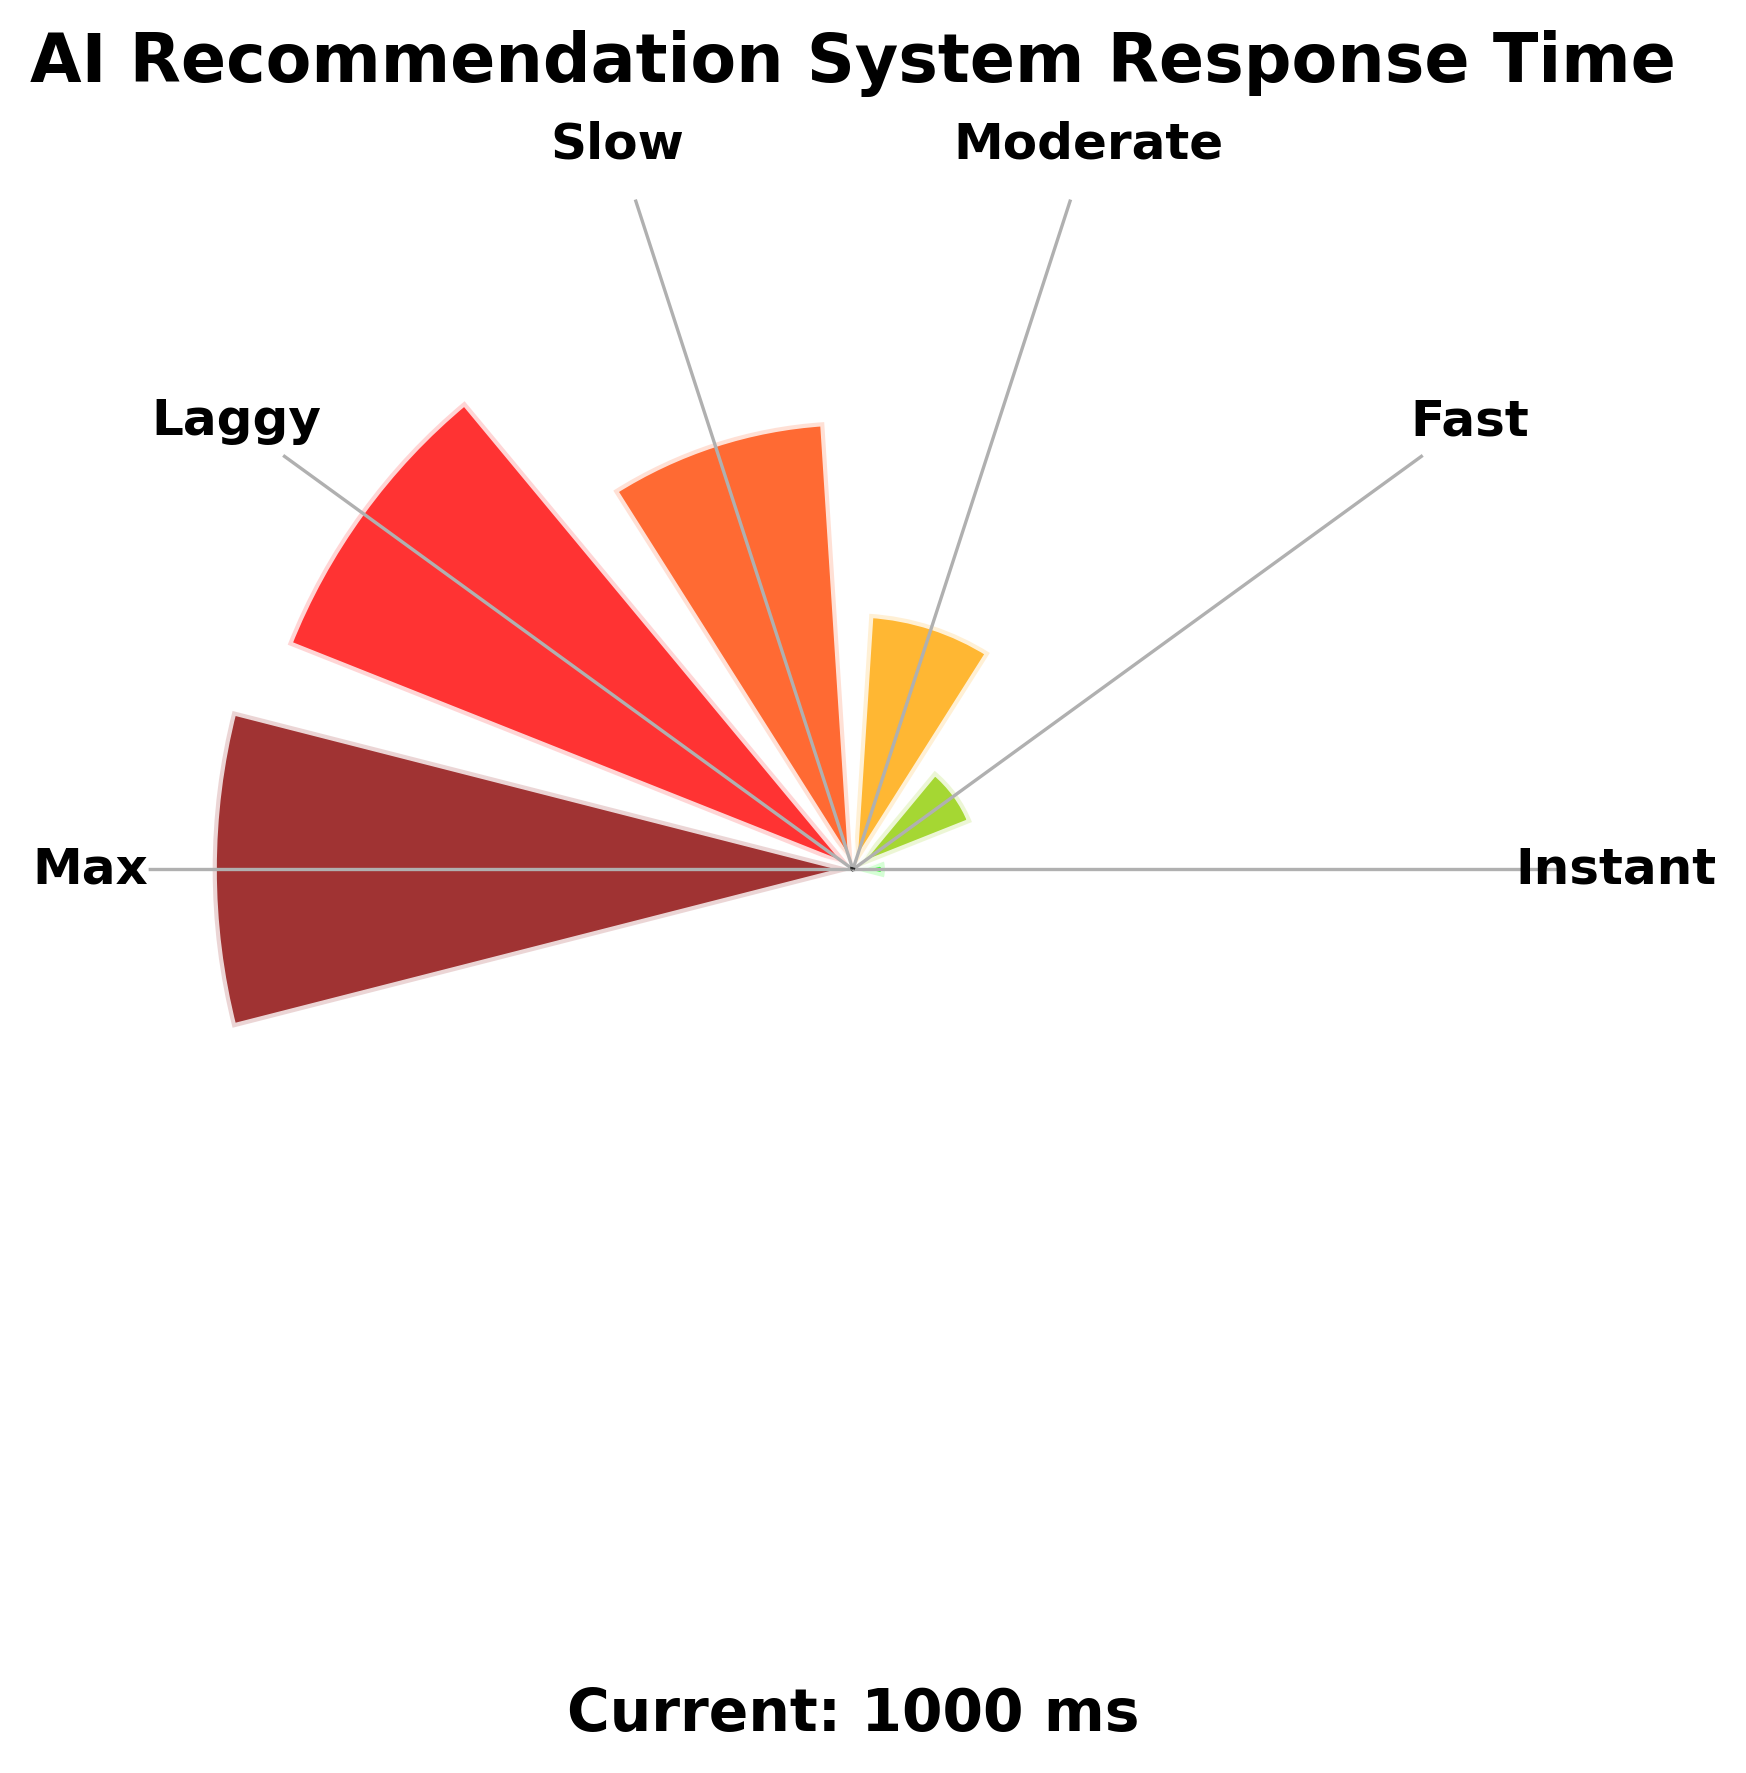What is the title of the figure? The title is displayed at the top of the figure in bold. It reads "AI Recommendation System Response Time".
Answer: AI Recommendation System Response Time What is the current response time shown by the needle? The current response time is annotated near the bottom of the gauge, indicated by the text "Current: <value> ms". Replace <value> with the corresponding number.
Answer: Current: <value> ms How many labeled segments are there in the gauge chart? Count the number of different labeled regions on the gauge chart.
Answer: Six Which segment is associated with a 50 ms response time? Identify the segment at 50 ms by looking at the labels aligned with the tick marks.
Answer: Instant Compare the color of the segments labeled "Fast" and "Slow". Which one is closer to red? "Fast" is colored greenish-yellow while "Slow" is orange-red. Since orange-red is closer to red, "Slow" is the answer.
Answer: Slow What is the range of response times represented as "Laggy"? Locate the label "Laggy" and note the range of milliseconds indicated by its position on the gauge. This is usually between 950 ms and 1000 ms.
Answer: 950-1000 ms What is the average value of the response times for "Instant" and "Moderate"? Sum the response times for "Instant" (50 ms) and "Moderate" (400 ms), then divide by 2. (50 + 400) / 2 = 225
Answer: 225 ms Which has a larger response time: "Moderate" or "Fast"? Locate both segments and compare their values. "Moderate" is 400 ms and "Fast" is 200 ms. Therefore, "Moderate" has a larger response time.
Answer: Moderate What is the difference between the values of "Slow" and "Max"? Subtract the value associated with the "Slow" segment (700 ms) from the "Max" segment (1000 ms). 1000 - 700 = 300
Answer: 300 ms Which segment has the highest response time and what is the color of that segment? The "Max" segment represents the highest response time, which is 1000 ms. The color associated with it is a very dark red.
Answer: Max, dark red 